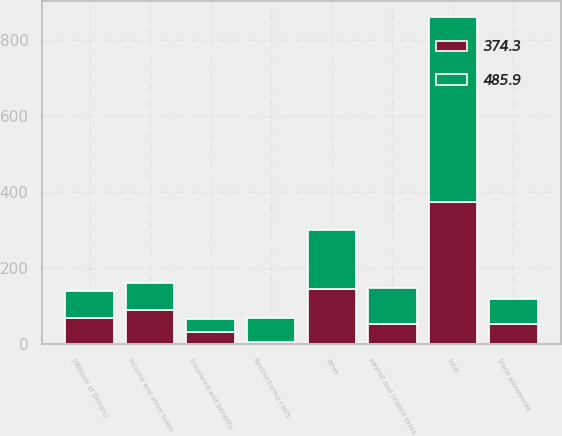Convert chart. <chart><loc_0><loc_0><loc_500><loc_500><stacked_bar_chart><ecel><fcel>(Millions of Dollars)<fcel>Income and other taxes<fcel>payroll and related taxes<fcel>trade allowances<fcel>Restructuring costs<fcel>Insurance and benefits<fcel>other<fcel>total<nl><fcel>485.9<fcel>69.05<fcel>72.7<fcel>94.5<fcel>65.4<fcel>63.1<fcel>35<fcel>155.2<fcel>485.9<nl><fcel>374.3<fcel>69.05<fcel>88.3<fcel>53<fcel>52.7<fcel>4.9<fcel>31.8<fcel>143.6<fcel>374.3<nl></chart> 